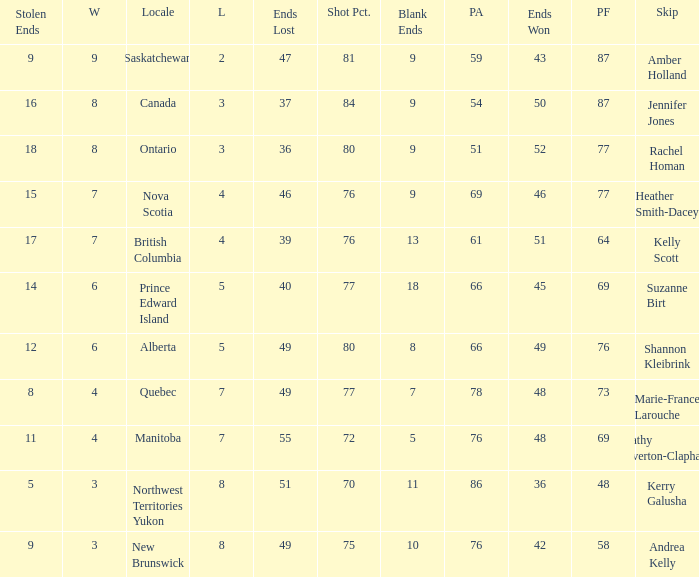If the locale is Ontario, what is the W minimum? 8.0. 